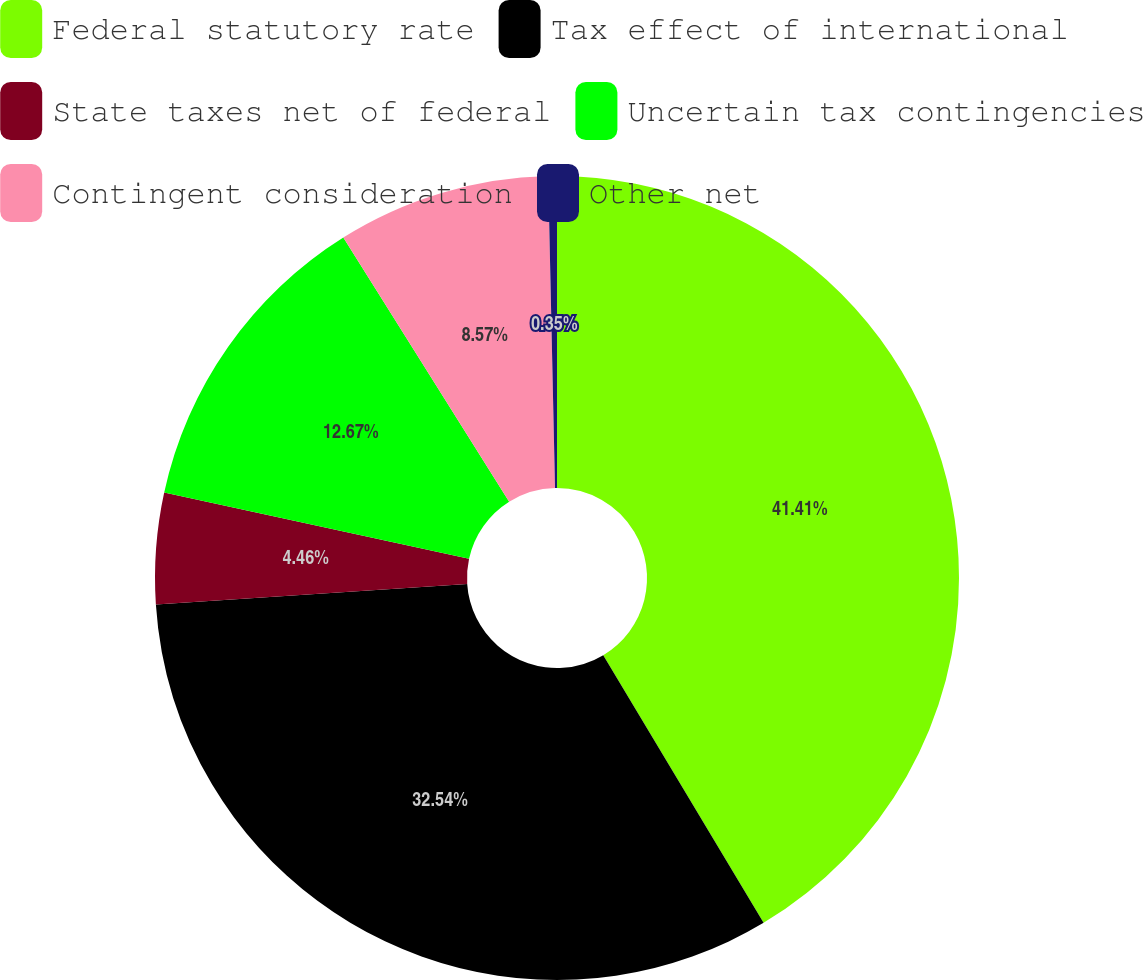Convert chart to OTSL. <chart><loc_0><loc_0><loc_500><loc_500><pie_chart><fcel>Federal statutory rate<fcel>Tax effect of international<fcel>State taxes net of federal<fcel>Uncertain tax contingencies<fcel>Contingent consideration<fcel>Other net<nl><fcel>41.41%<fcel>32.54%<fcel>4.46%<fcel>12.67%<fcel>8.57%<fcel>0.35%<nl></chart> 